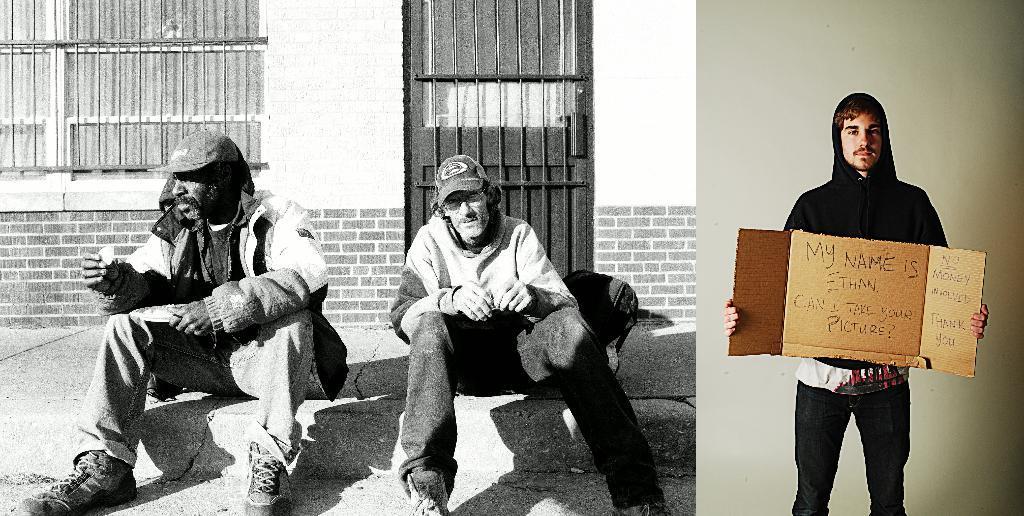How would you summarize this image in a sentence or two? In this image we can see collage of two pictures. In which we can see three persons. Two persons are sitting on the floor. One person is holding a plate in his hand. One person is holding a board in his hands. In the background we can see a bag placed on the ground , a building with window and a door. 